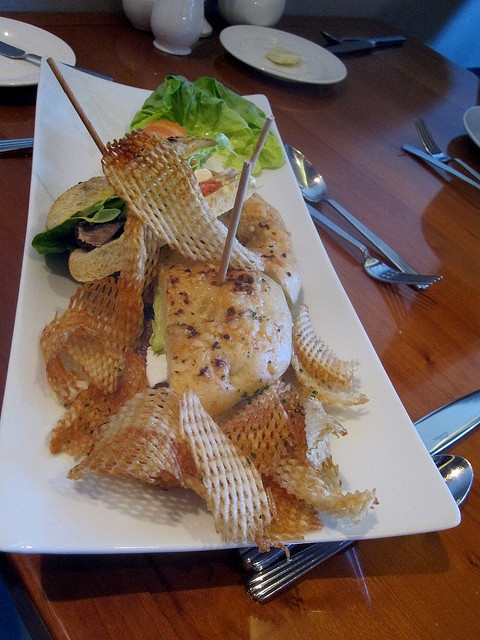Describe the objects in this image and their specific colors. I can see dining table in darkblue, maroon, black, gray, and brown tones, sandwich in darkblue, tan, olive, gray, and darkgray tones, sandwich in darkblue, black, olive, and tan tones, sandwich in darkblue, darkgray, tan, gray, and brown tones, and spoon in darkblue, black, gray, navy, and darkgray tones in this image. 